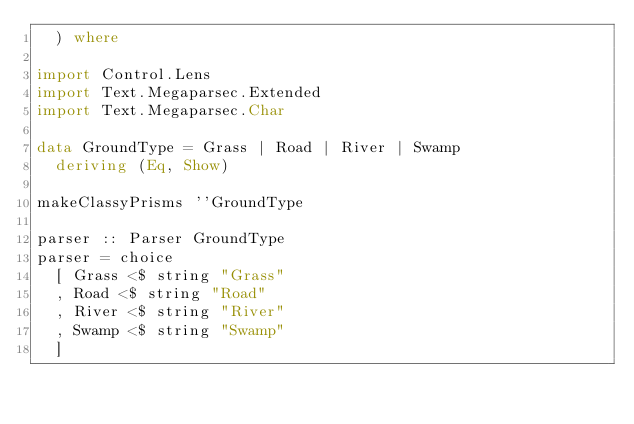<code> <loc_0><loc_0><loc_500><loc_500><_Haskell_>  ) where

import Control.Lens
import Text.Megaparsec.Extended
import Text.Megaparsec.Char

data GroundType = Grass | Road | River | Swamp
  deriving (Eq, Show)

makeClassyPrisms ''GroundType

parser :: Parser GroundType
parser = choice
  [ Grass <$ string "Grass"
  , Road <$ string "Road"
  , River <$ string "River"
  , Swamp <$ string "Swamp"
  ]
</code> 